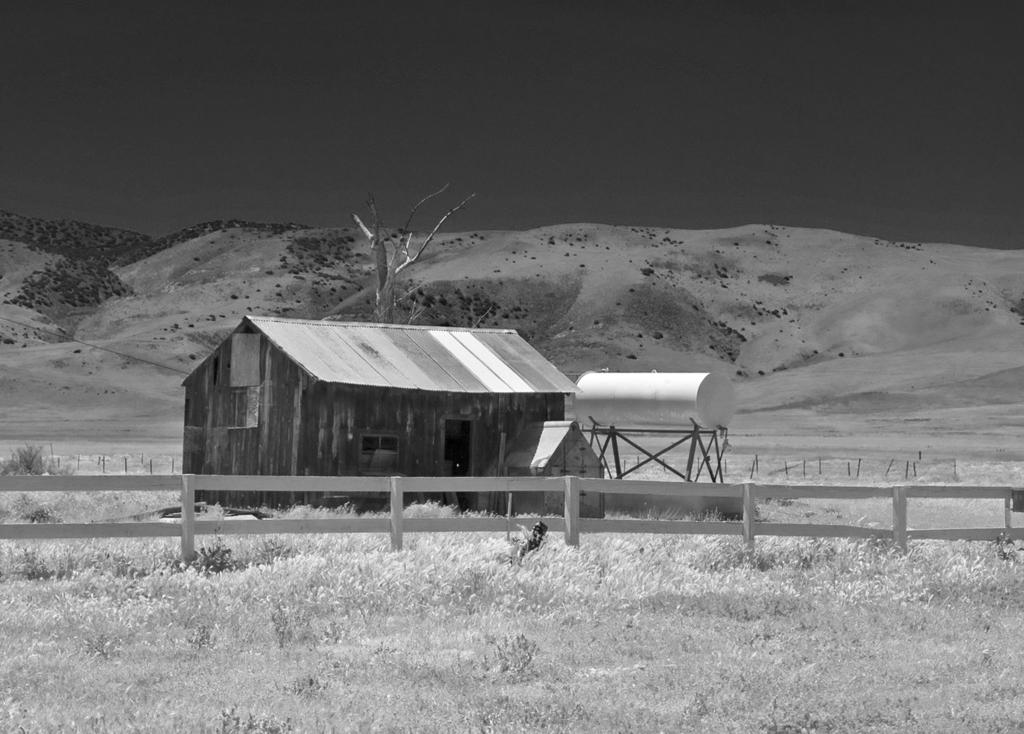What type of structure can be seen in the image? There is a shed in the image. What is the purpose of the railing in the image? The purpose of the railing is not specified, but it could be for safety or decoration. What is the object on the metal stand in the image? The facts do not specify what the object on the metal stand is. What type of vegetation is visible in the image? There is grass visible in the image. What can be seen in the background of the image? There is a tree, mountains, and the sky visible in the background of the image. What type of jewel is hanging from the tree in the image? There is no jewel hanging from the tree in the image; only a tree is visible in the background. What type of chain is connecting the mountains to the sky in the image? There is no chain connecting the mountains to the sky in the image; the mountains and sky are separate elements in the background. 